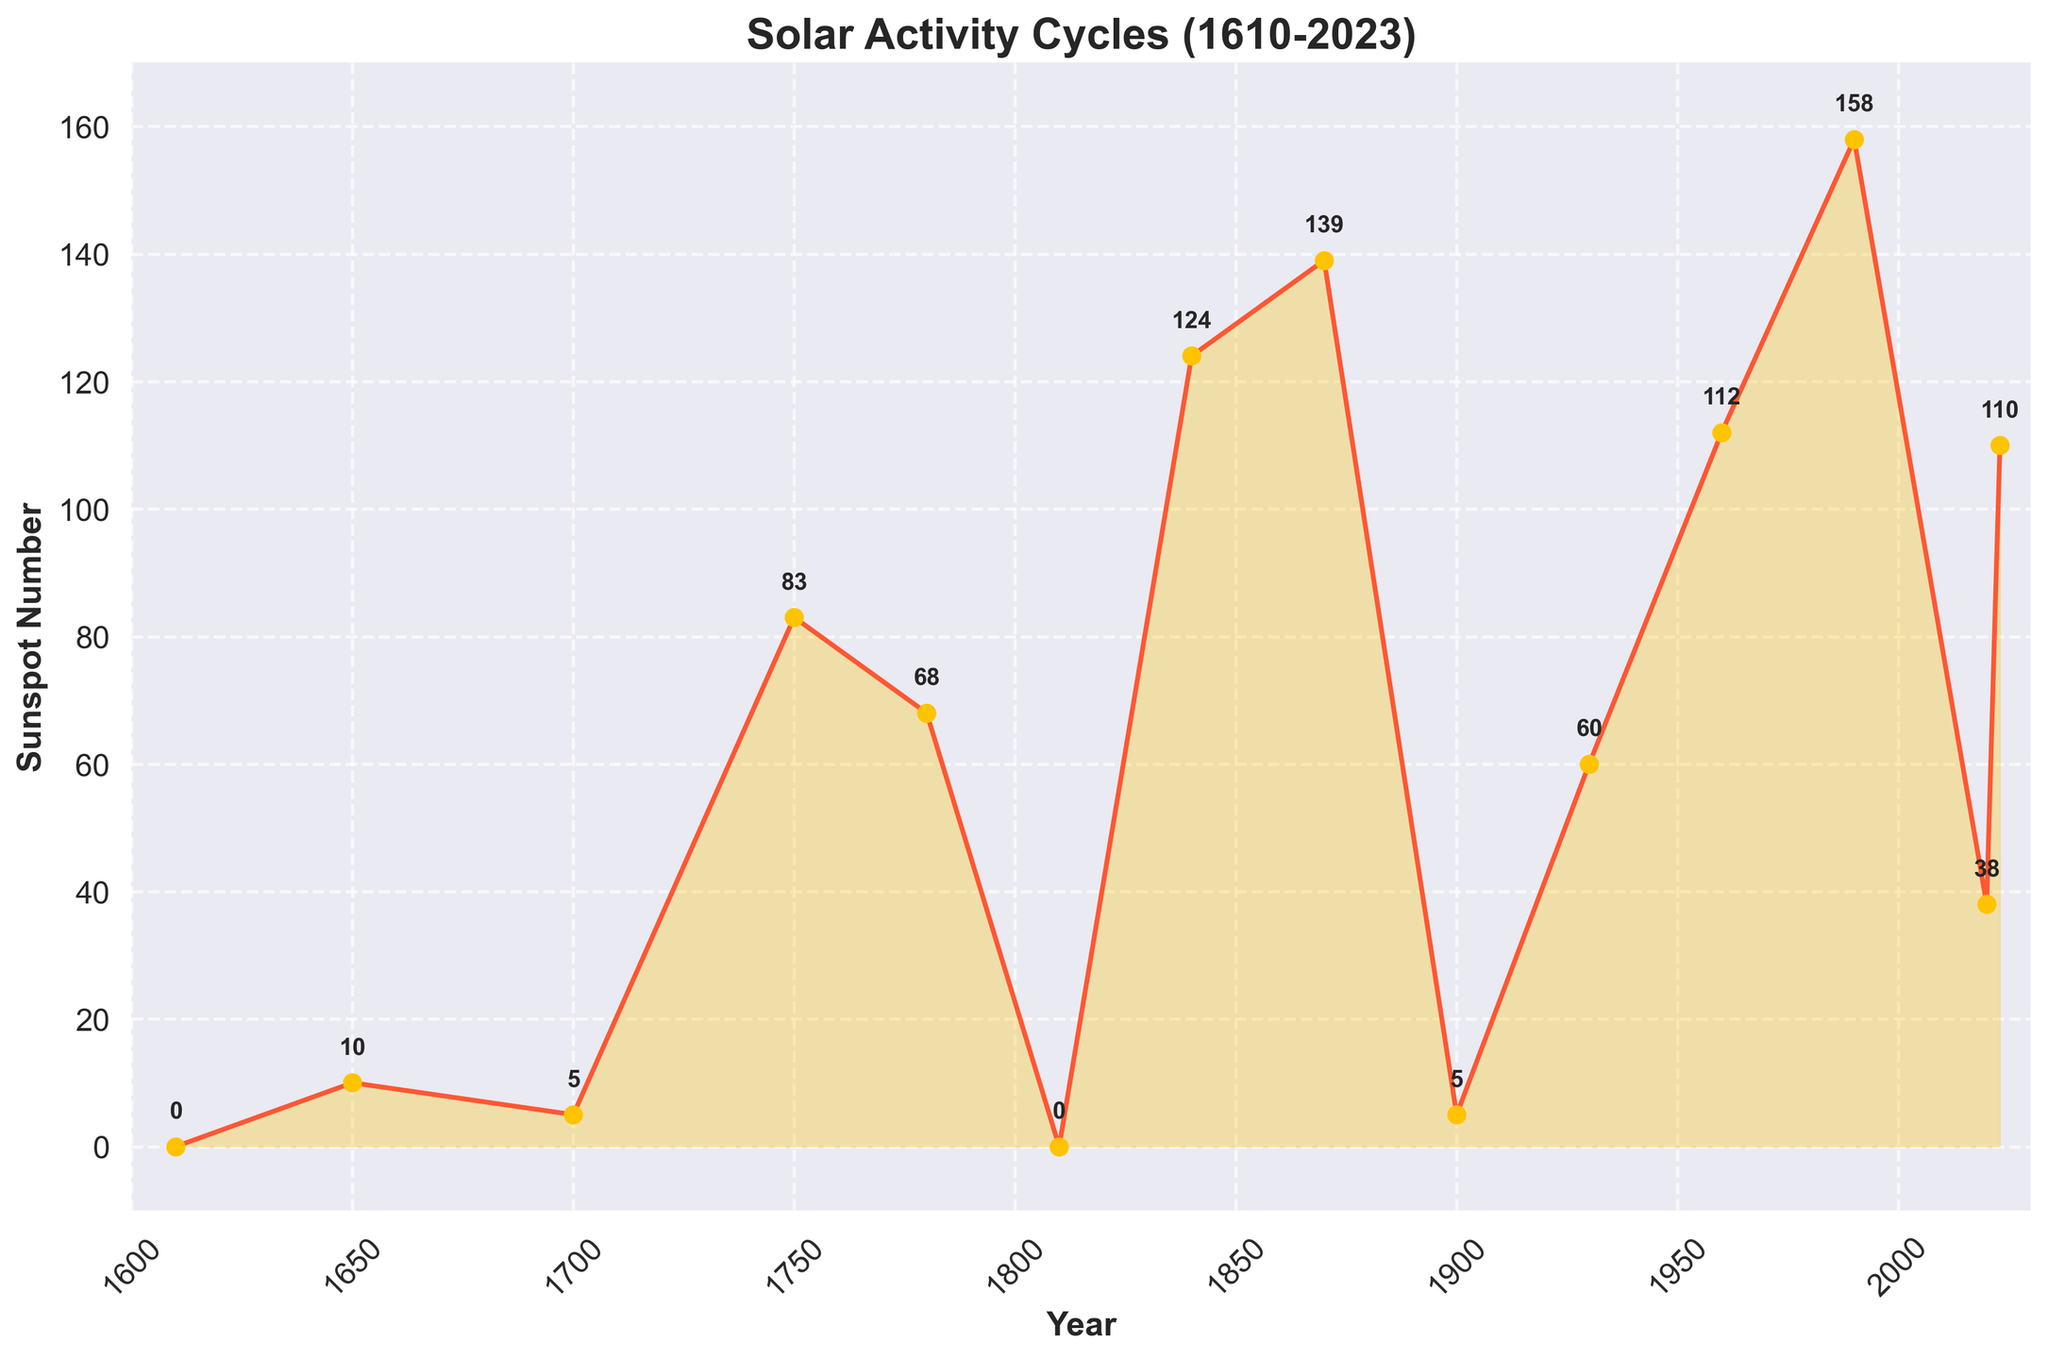What's the highest sunspot number in the data? Look at the y-axis and the data points to determine the highest y-value. The peak occurs in 1990 with a sunspot number of 158.
Answer: 158 Which year had the lowest recorded sunspot number? Scan the y-values to find the lowest point. The years 1610, 1810, and 1900 all show a sunspot number of 0.
Answer: 1610, 1810, 1900 Compare the sunspot numbers between 1750 and 1840. Which year had more sunspots and by how many? For 1750, the sunspot number is 83. For 1840, the sunspot number is 124. Calculate the difference: 124 - 83 = 41.
Answer: 1840 by 41 What is the average sunspot number from 1960 to 2023? Identify the sunspot numbers in the years 1960, 1990, 2020, and 2023. Then calculate the average: (112 + 158 + 38 + 110) / 4 = 418 / 4 = 104.5.
Answer: 104.5 Between the years 1700 and 1810, what is the total increase in sunspot numbers? Identify the sunspot numbers for 1700 and 1810: 5 and 0. Calculate the total difference from 5 to peak at 83 (1750) + 68 (1780) + 0 (1810). Sum the differences: (83 - 5) + (68 - 83) + (0 - 68) = 78 - 15 - 68 = -5. There's no increase; actually, it's a decline.
Answer: -5 What visual cue indicates a peak in solar activity in the plot? Look for the highest peaks in the line plot which typically have higher sunspot numbers indicated by the data points.
Answer: Highest peaks in the line plot How many times did the sunspot number exceed 100 in the observations? Identify the years where the y-value exceeds 100: The years 1840, 1870, 1960, and 1990. Count these occurrences.
Answer: 4 What is the trend of sunspot numbers from 1990 to 2023? Observe the change in y-values from 1990 (158) to 2023 (110). The sunspot number decreases and then slightly increases again in 2023.
Answer: Decreasing then slightly increasing Describe the color used for the line plot and markers. How does it help in visualizing the data? The line is a reddish-orange, the markers are a yellow shade with a darker border. Such bright contrasting colors help to clearly distinguish between data points and make trends more visible.
Answer: Reddish-orange line, yellow markers with dark borders 